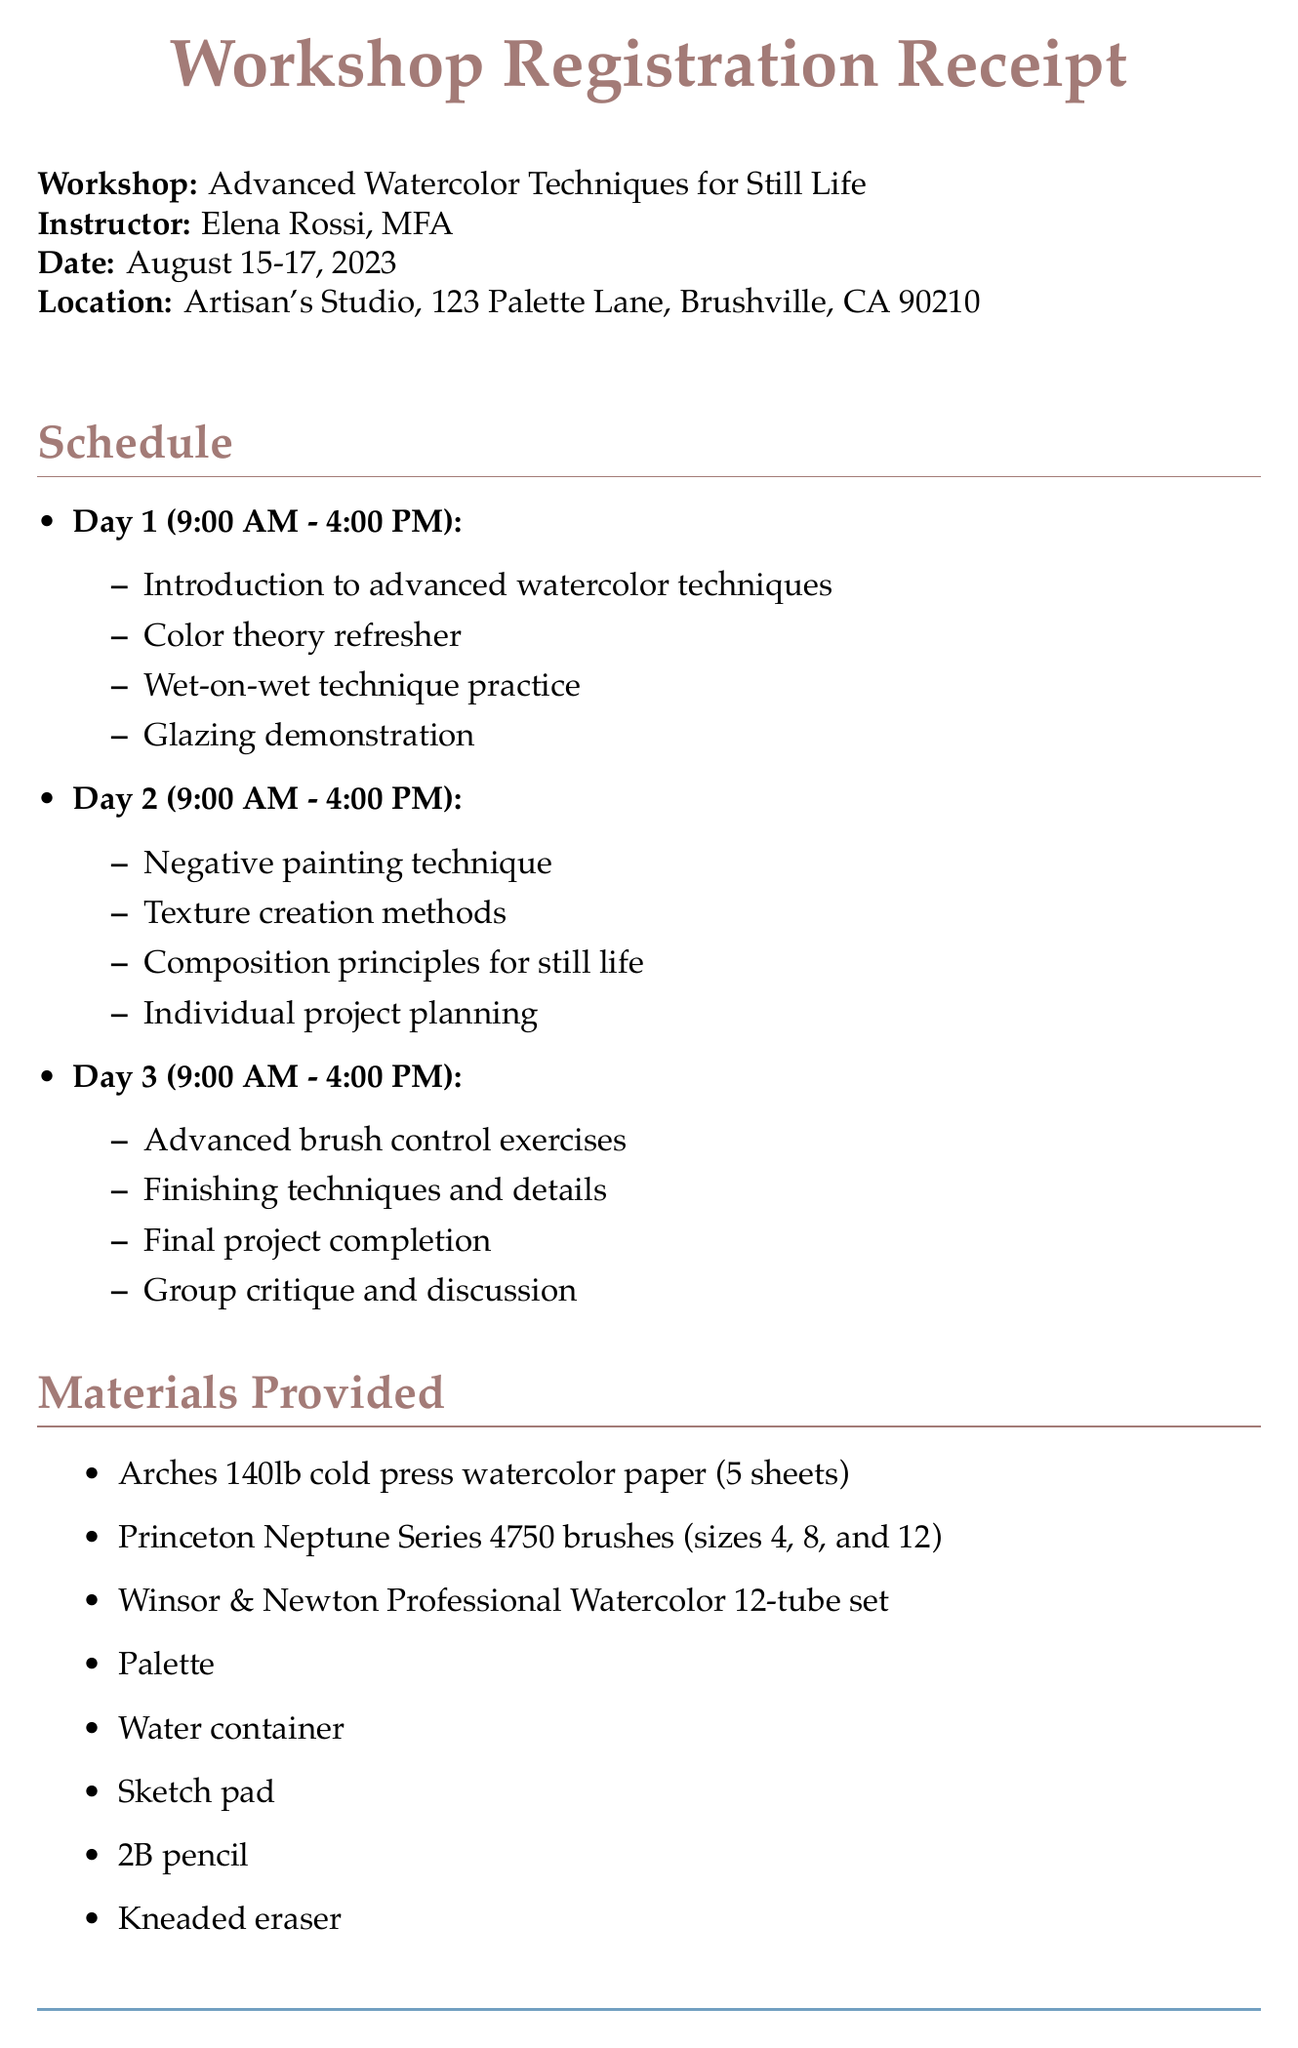What is the workshop name? The workshop name is clearly stated in the document as "Advanced Watercolor Techniques for Still Life."
Answer: Advanced Watercolor Techniques for Still Life Who is the instructor? The instructor's name is provided as "Elena Rossi, MFA."
Answer: Elena Rossi, MFA What is the total cost of the workshop? The document specifies that the total cost is $450.00.
Answer: $450.00 On which days will the workshop take place? The document indicates the workshop dates are August 15-17, 2023.
Answer: August 15-17, 2023 What materials are provided? A list of materials is detailed, including watercolor paper, brushes, and a watercolor set, among others.
Answer: Arches 140lb cold press watercolor paper (5 sheets), Princeton Neptune Series 4750 brushes (sizes 4, 8, and 12), Winsor & Newton Professional Watercolor 12-tube set What technique involves applying color on wet surfaces? The document lists "Wet-on-wet application" as one of the techniques taught.
Answer: Wet-on-wet application How many days does the workshop span? The number of days for the workshop is mentioned, which is 3 days.
Answer: 3 days What special notes are provided for participants? The document states that participants should bring a smock or apron and personal brushes.
Answer: Please bring a smock or apron, and any personal brushes you'd like to use 